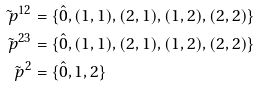Convert formula to latex. <formula><loc_0><loc_0><loc_500><loc_500>\tilde { \ p } ^ { 1 2 } & = \{ \hat { 0 } , ( 1 , 1 ) , ( 2 , 1 ) , ( 1 , 2 ) , ( 2 , 2 ) \} \\ \tilde { \ p } ^ { 2 3 } & = \{ \hat { 0 } , ( 1 , 1 ) , ( 2 , 1 ) , ( 1 , 2 ) , ( 2 , 2 ) \} \\ \tilde { \ p } ^ { 2 } & = \{ \hat { 0 } , 1 , 2 \}</formula> 